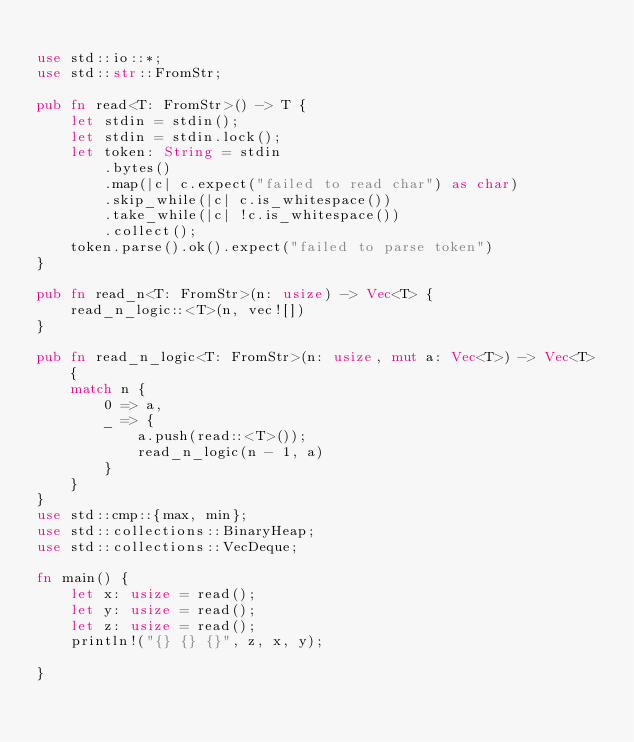<code> <loc_0><loc_0><loc_500><loc_500><_Rust_>
use std::io::*;
use std::str::FromStr;

pub fn read<T: FromStr>() -> T {
    let stdin = stdin();
    let stdin = stdin.lock();
    let token: String = stdin
        .bytes()
        .map(|c| c.expect("failed to read char") as char)
        .skip_while(|c| c.is_whitespace())
        .take_while(|c| !c.is_whitespace())
        .collect();
    token.parse().ok().expect("failed to parse token")
}

pub fn read_n<T: FromStr>(n: usize) -> Vec<T> {
    read_n_logic::<T>(n, vec![])
}

pub fn read_n_logic<T: FromStr>(n: usize, mut a: Vec<T>) -> Vec<T> {
    match n {
        0 => a,
        _ => {
            a.push(read::<T>());
            read_n_logic(n - 1, a)
        }
    }
}
use std::cmp::{max, min};
use std::collections::BinaryHeap;
use std::collections::VecDeque;

fn main() {
    let x: usize = read();
    let y: usize = read();
    let z: usize = read();
    println!("{} {} {}", z, x, y);

}
</code> 